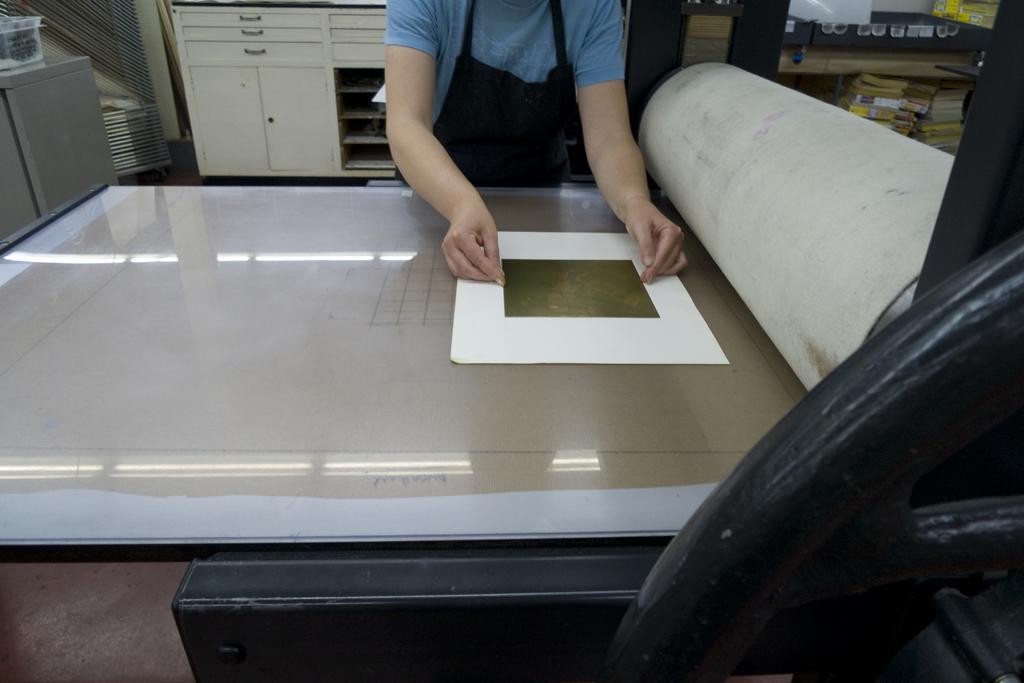Describe this image in one or two sentences. In this image we can see some person standing in front of the glass table and on the glass table we can see a paper. In the background we can see the shelf and also see some books placed in the rack. Floor is also visible. On the left there is an object. 